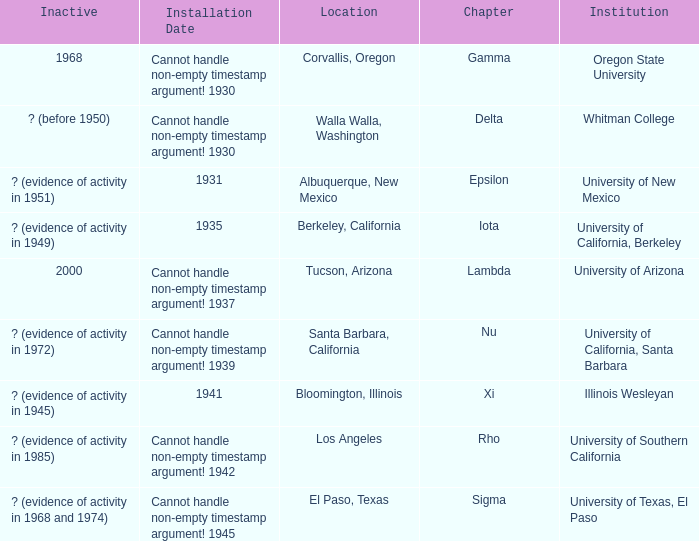What does the inactive state for University of Texas, El Paso?  ? (evidence of activity in 1968 and 1974). 